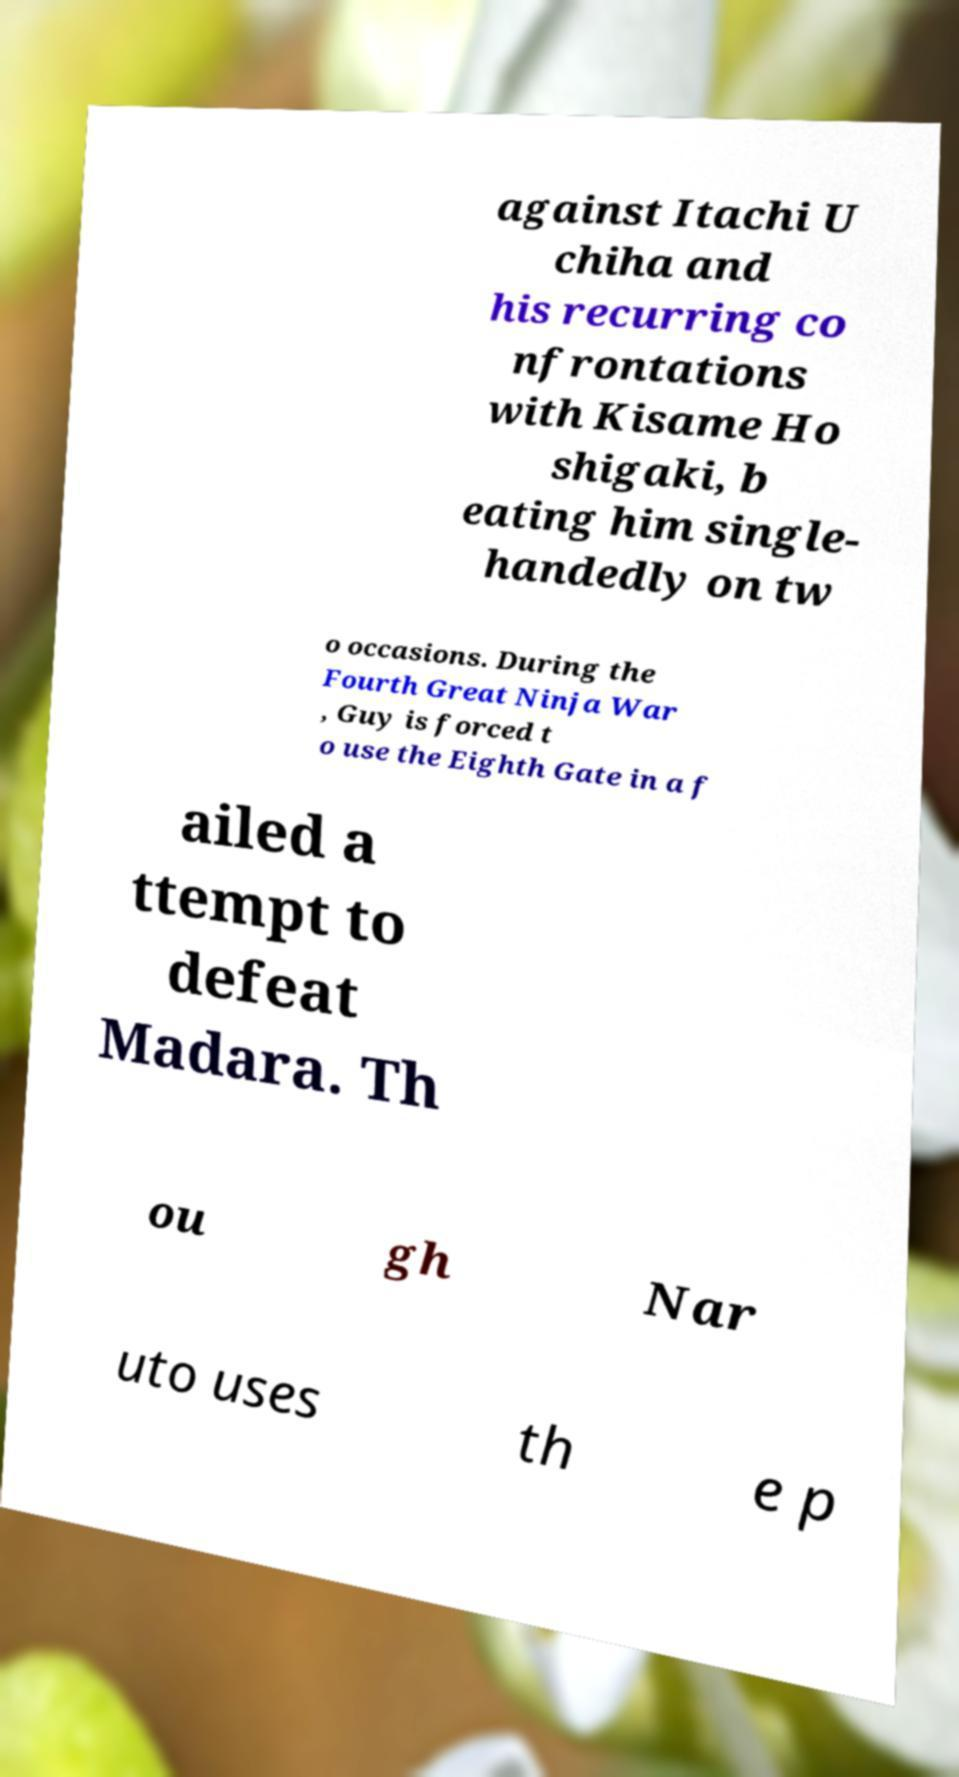Could you extract and type out the text from this image? against Itachi U chiha and his recurring co nfrontations with Kisame Ho shigaki, b eating him single- handedly on tw o occasions. During the Fourth Great Ninja War , Guy is forced t o use the Eighth Gate in a f ailed a ttempt to defeat Madara. Th ou gh Nar uto uses th e p 